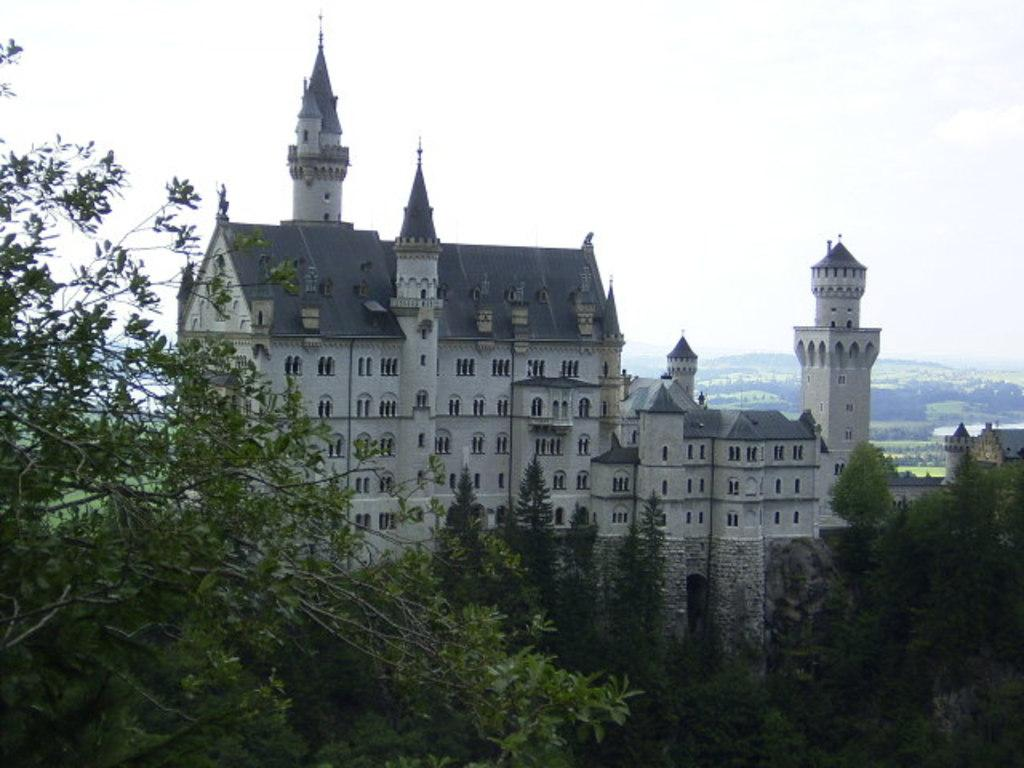What type of structure is in the image? There is a castle in the image. What type of natural elements can be seen in the image? There are trees, plants, and mountains in the image. What is visible in the background of the image? The sky is visible in the background of the image. What type of brain surgery is being performed in the image? There is no brain or hospital present in the image; it features a castle, trees, plants, mountains, and the sky. 